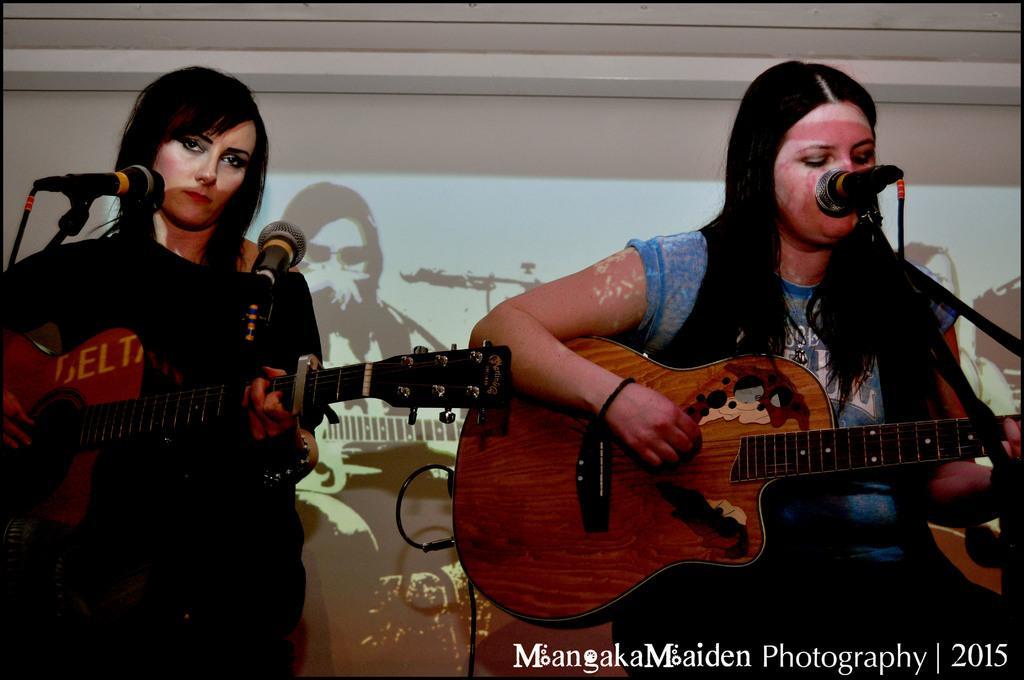Could you give a brief overview of what you see in this image? In the image there are two women's sitting on chair and playing their musical instruments in front of a microphone. In background there is a screen and a wall which is in white color. 